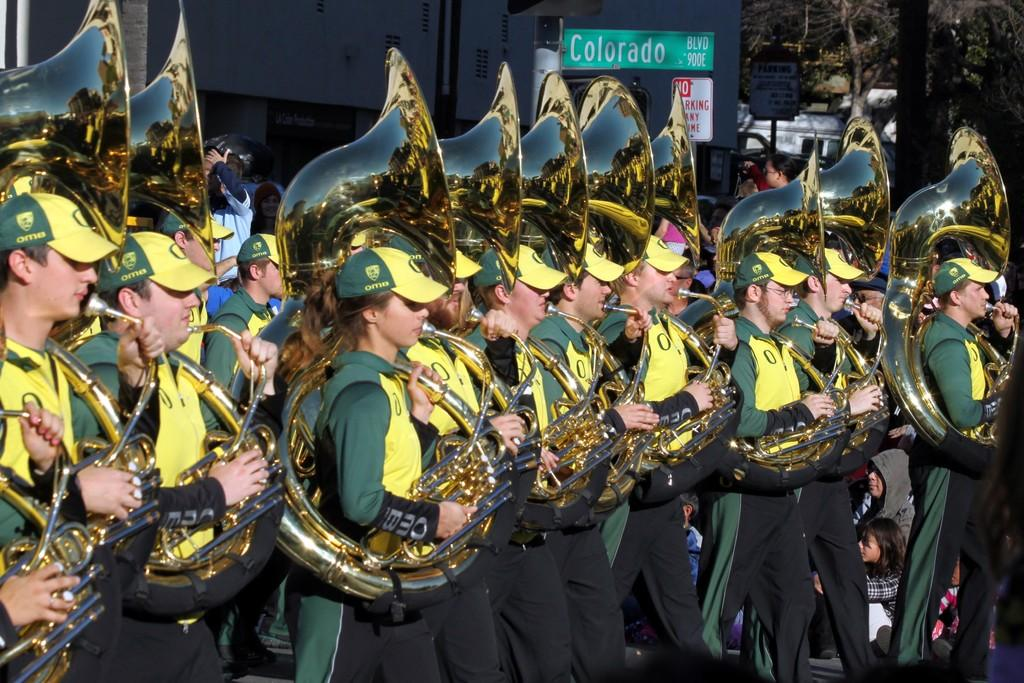What are the people in the image doing? The people in the image are standing and playing musical instruments. What are the people wearing on their heads? The people are wearing caps. What can be seen in the background of the image? There are trees and boards in the background of the image. What type of bottle is being used to push the people while they play their instruments? There is no bottle present in the image, nor is there any indication that the people are being pushed while playing their instruments. 